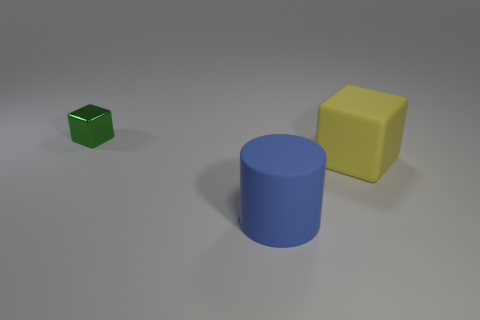There is a block that is in front of the metallic thing; what number of cylinders are in front of it?
Provide a succinct answer. 1. There is a block in front of the small metal object; is it the same color as the thing to the left of the big blue thing?
Keep it short and to the point. No. There is a yellow cube that is the same size as the blue rubber thing; what material is it?
Provide a succinct answer. Rubber. There is a big thing in front of the block on the right side of the object left of the big blue matte cylinder; what is its shape?
Make the answer very short. Cylinder. There is another matte object that is the same size as the yellow object; what shape is it?
Offer a terse response. Cylinder. There is a rubber object that is in front of the block that is right of the shiny thing; what number of things are right of it?
Make the answer very short. 1. Are there more small green shiny objects that are behind the metal object than large things that are right of the large cylinder?
Make the answer very short. No. How many other tiny objects are the same shape as the yellow matte thing?
Offer a very short reply. 1. How many objects are rubber objects right of the blue cylinder or objects to the left of the big yellow matte object?
Your response must be concise. 3. What material is the block right of the object that is left of the object in front of the yellow rubber object?
Offer a very short reply. Rubber. 